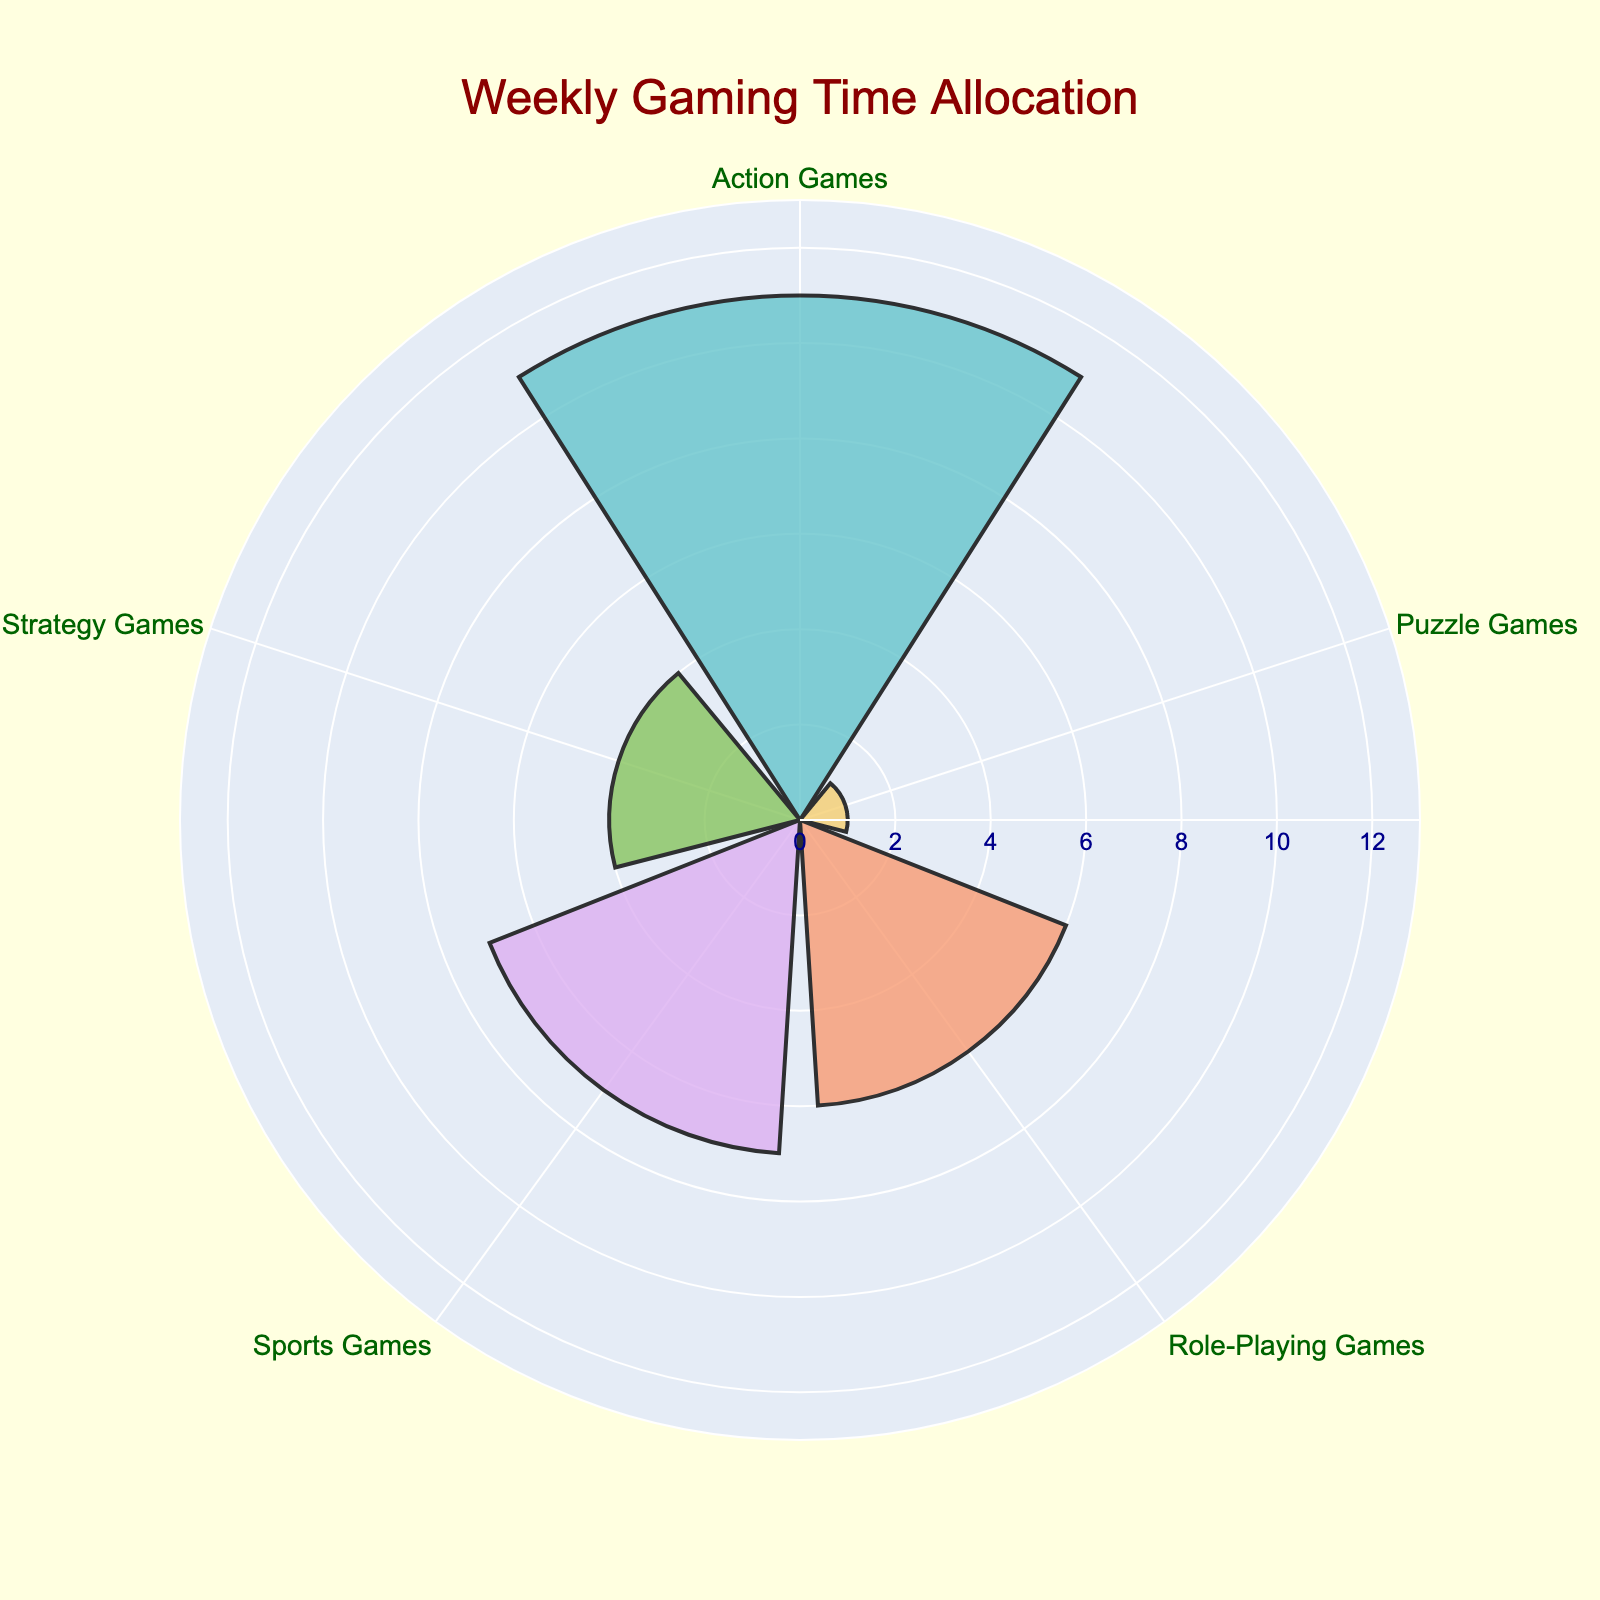What's the title of the plot? The title is displayed at the top of the plot.
Answer: "Weekly Gaming Time Allocation" How many categories are displayed on the plot? Each category is represented by a segment along the radial axis.
Answer: 5 What is the category with the highest total gaming hours? By looking at which segment extends furthest from the center, we can identify the category with the highest total hours.
Answer: "Action Games" What's the total number of hours spent playing Role-Playing Games? Sum the contributions from each day in the DataFrame for Role-Playing Games, and these are reflected in the bars for that category. 3+1+1 = 5
Answer: 5 hours Which category has the least total gaming hours? By identifying the shortest segment on the plot, we find the category with the least hours.
Answer: "Puzzle Games" How many more hours are spent on Action Games than on Strategy Games? Compare the lengths of the segments for Action Games and Strategy Games by subtracting Strategy Games' hours from Action Games' hours (2+2+2+3 = 9) - (2+2 = 4).
Answer: 5 hours What's the combined total of hours for Strategy Games and Puzzle Games? Sum the hours from the segments of Strategy Games and Puzzle Games. 2+2 = 4 (Strategy Games) + 1 (Puzzle Games) = 5
Answer: 5 hours On which day is the most time spent on sports games? Locate the segments corresponding to sports games and identify the one with the largest radius which indicates the highest value, related to the dataset, it's Saturday.
Answer: "Saturday" How many segments are in the rose chart? Count the total number of segments/bars in the rose chart.
Answer: 5 